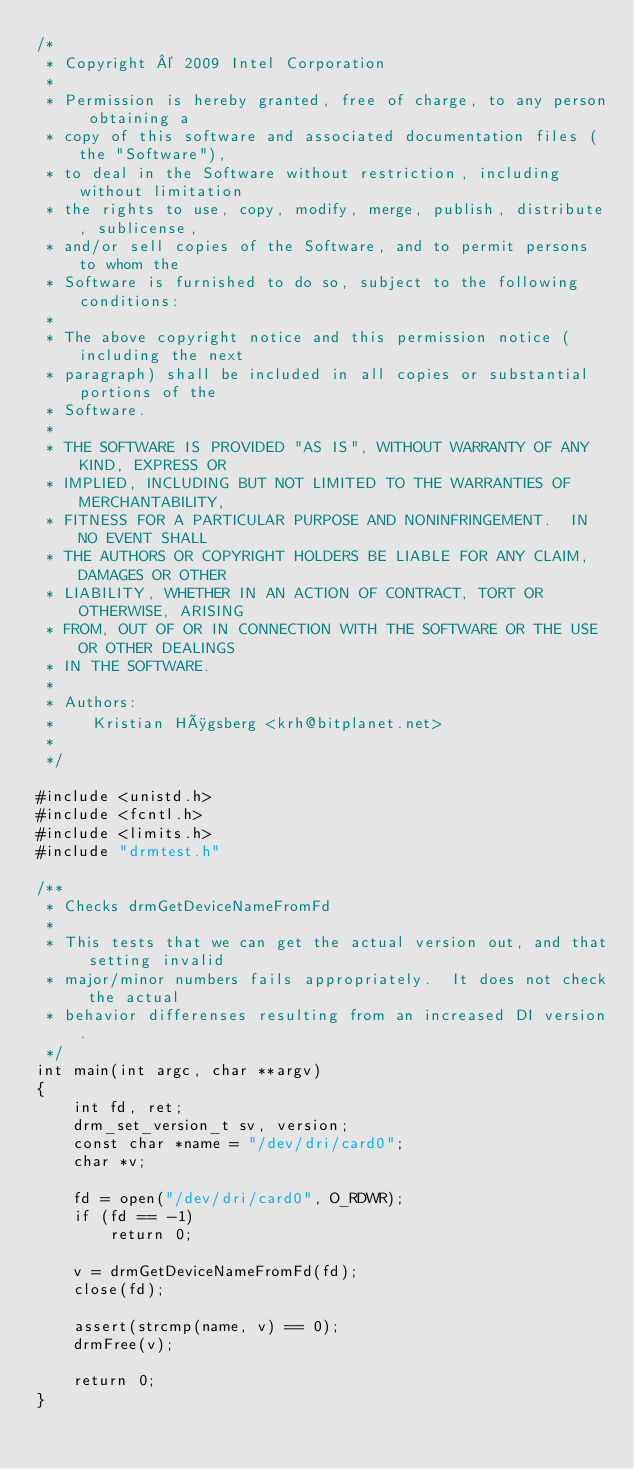<code> <loc_0><loc_0><loc_500><loc_500><_C_>/*
 * Copyright © 2009 Intel Corporation
 *
 * Permission is hereby granted, free of charge, to any person obtaining a
 * copy of this software and associated documentation files (the "Software"),
 * to deal in the Software without restriction, including without limitation
 * the rights to use, copy, modify, merge, publish, distribute, sublicense,
 * and/or sell copies of the Software, and to permit persons to whom the
 * Software is furnished to do so, subject to the following conditions:
 *
 * The above copyright notice and this permission notice (including the next
 * paragraph) shall be included in all copies or substantial portions of the
 * Software.
 *
 * THE SOFTWARE IS PROVIDED "AS IS", WITHOUT WARRANTY OF ANY KIND, EXPRESS OR
 * IMPLIED, INCLUDING BUT NOT LIMITED TO THE WARRANTIES OF MERCHANTABILITY,
 * FITNESS FOR A PARTICULAR PURPOSE AND NONINFRINGEMENT.  IN NO EVENT SHALL
 * THE AUTHORS OR COPYRIGHT HOLDERS BE LIABLE FOR ANY CLAIM, DAMAGES OR OTHER
 * LIABILITY, WHETHER IN AN ACTION OF CONTRACT, TORT OR OTHERWISE, ARISING
 * FROM, OUT OF OR IN CONNECTION WITH THE SOFTWARE OR THE USE OR OTHER DEALINGS
 * IN THE SOFTWARE.
 *
 * Authors:
 *    Kristian Høgsberg <krh@bitplanet.net>
 *
 */

#include <unistd.h>
#include <fcntl.h>
#include <limits.h>
#include "drmtest.h"

/**
 * Checks drmGetDeviceNameFromFd
 *
 * This tests that we can get the actual version out, and that setting invalid
 * major/minor numbers fails appropriately.  It does not check the actual
 * behavior differenses resulting from an increased DI version.
 */
int main(int argc, char **argv)
{
	int fd, ret;
	drm_set_version_t sv, version;
	const char *name = "/dev/dri/card0";
	char *v;

	fd = open("/dev/dri/card0", O_RDWR);
	if (fd == -1)
		return 0;

	v = drmGetDeviceNameFromFd(fd);
	close(fd);

	assert(strcmp(name, v) == 0);
	drmFree(v);

	return 0;
}
</code> 